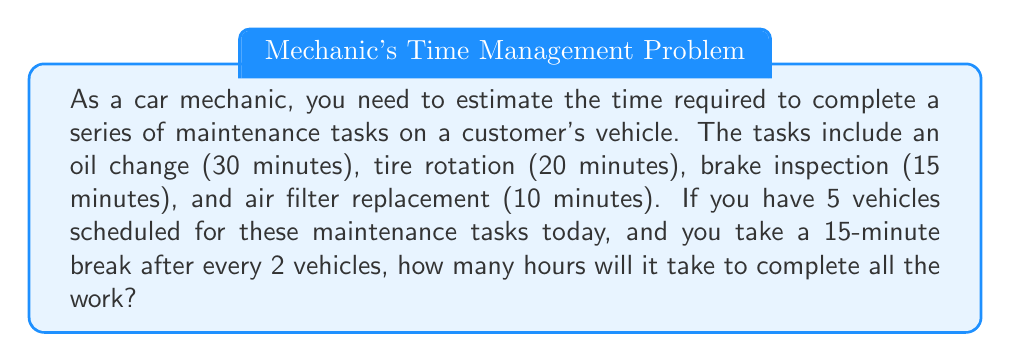Provide a solution to this math problem. Let's break this down step-by-step:

1. Calculate the time for one vehicle's maintenance:
   Oil change + Tire rotation + Brake inspection + Air filter replacement
   $30 + 20 + 15 + 10 = 75$ minutes

2. Time for 5 vehicles:
   $75 \times 5 = 375$ minutes

3. Number of breaks:
   There will be 2 breaks (one after every 2 vehicles)
   $2 \times 15 = 30$ minutes for breaks

4. Total time:
   Maintenance time + Break time
   $375 + 30 = 405$ minutes

5. Convert minutes to hours:
   $405 \div 60 = 6.75$ hours

Therefore, it will take 6.75 hours to complete all the maintenance tasks for 5 vehicles, including breaks.
Answer: 6.75 hours 